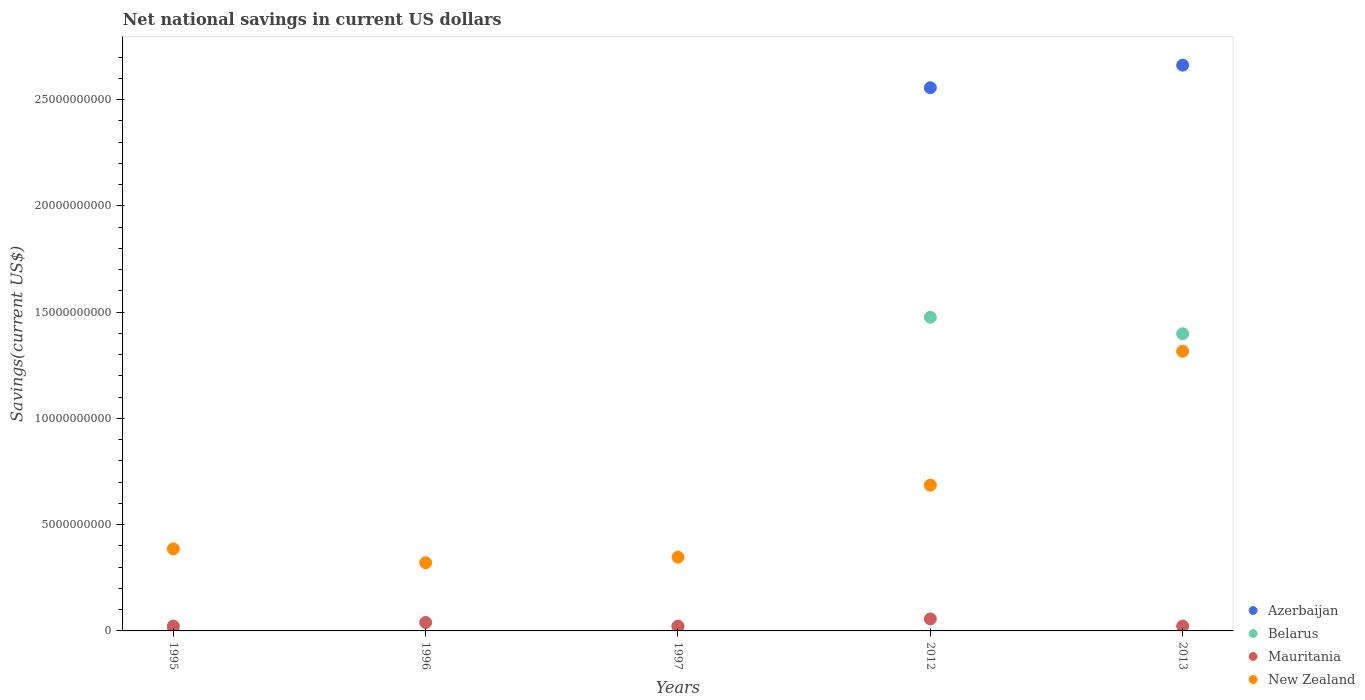How many different coloured dotlines are there?
Ensure brevity in your answer.  4. Across all years, what is the maximum net national savings in Mauritania?
Your answer should be compact. 5.65e+08. Across all years, what is the minimum net national savings in Mauritania?
Offer a terse response. 2.26e+08. In which year was the net national savings in Mauritania maximum?
Your response must be concise. 2012. What is the total net national savings in Mauritania in the graph?
Make the answer very short. 1.64e+09. What is the difference between the net national savings in New Zealand in 1997 and that in 2013?
Offer a very short reply. -9.69e+09. What is the difference between the net national savings in Mauritania in 1997 and the net national savings in Azerbaijan in 1996?
Offer a terse response. 2.26e+08. What is the average net national savings in Azerbaijan per year?
Make the answer very short. 1.04e+1. In the year 2012, what is the difference between the net national savings in New Zealand and net national savings in Belarus?
Keep it short and to the point. -7.90e+09. What is the ratio of the net national savings in Mauritania in 1996 to that in 2012?
Ensure brevity in your answer.  0.71. Is the difference between the net national savings in New Zealand in 1997 and 2013 greater than the difference between the net national savings in Belarus in 1997 and 2013?
Your answer should be very brief. Yes. What is the difference between the highest and the second highest net national savings in Belarus?
Offer a terse response. 7.80e+08. What is the difference between the highest and the lowest net national savings in Belarus?
Ensure brevity in your answer.  1.48e+1. Is the sum of the net national savings in Mauritania in 1996 and 2012 greater than the maximum net national savings in Azerbaijan across all years?
Your answer should be very brief. No. Is it the case that in every year, the sum of the net national savings in New Zealand and net national savings in Belarus  is greater than the sum of net national savings in Mauritania and net national savings in Azerbaijan?
Your answer should be compact. No. Is the net national savings in Belarus strictly greater than the net national savings in Mauritania over the years?
Your answer should be compact. No. Is the net national savings in Azerbaijan strictly less than the net national savings in New Zealand over the years?
Offer a terse response. No. What is the difference between two consecutive major ticks on the Y-axis?
Offer a terse response. 5.00e+09. Are the values on the major ticks of Y-axis written in scientific E-notation?
Give a very brief answer. No. Does the graph contain any zero values?
Keep it short and to the point. Yes. What is the title of the graph?
Keep it short and to the point. Net national savings in current US dollars. Does "Dominican Republic" appear as one of the legend labels in the graph?
Ensure brevity in your answer.  No. What is the label or title of the Y-axis?
Provide a succinct answer. Savings(current US$). What is the Savings(current US$) in Mauritania in 1995?
Ensure brevity in your answer.  2.28e+08. What is the Savings(current US$) in New Zealand in 1995?
Keep it short and to the point. 3.86e+09. What is the Savings(current US$) of Mauritania in 1996?
Keep it short and to the point. 3.98e+08. What is the Savings(current US$) of New Zealand in 1996?
Keep it short and to the point. 3.21e+09. What is the Savings(current US$) in Belarus in 1997?
Ensure brevity in your answer.  2.06e+08. What is the Savings(current US$) in Mauritania in 1997?
Keep it short and to the point. 2.26e+08. What is the Savings(current US$) in New Zealand in 1997?
Ensure brevity in your answer.  3.47e+09. What is the Savings(current US$) of Azerbaijan in 2012?
Ensure brevity in your answer.  2.56e+1. What is the Savings(current US$) in Belarus in 2012?
Your answer should be compact. 1.48e+1. What is the Savings(current US$) in Mauritania in 2012?
Your answer should be very brief. 5.65e+08. What is the Savings(current US$) of New Zealand in 2012?
Provide a short and direct response. 6.86e+09. What is the Savings(current US$) in Azerbaijan in 2013?
Provide a succinct answer. 2.66e+1. What is the Savings(current US$) in Belarus in 2013?
Offer a terse response. 1.40e+1. What is the Savings(current US$) of Mauritania in 2013?
Your response must be concise. 2.26e+08. What is the Savings(current US$) in New Zealand in 2013?
Give a very brief answer. 1.32e+1. Across all years, what is the maximum Savings(current US$) of Azerbaijan?
Keep it short and to the point. 2.66e+1. Across all years, what is the maximum Savings(current US$) in Belarus?
Your response must be concise. 1.48e+1. Across all years, what is the maximum Savings(current US$) of Mauritania?
Give a very brief answer. 5.65e+08. Across all years, what is the maximum Savings(current US$) in New Zealand?
Make the answer very short. 1.32e+1. Across all years, what is the minimum Savings(current US$) of Azerbaijan?
Ensure brevity in your answer.  0. Across all years, what is the minimum Savings(current US$) of Mauritania?
Provide a succinct answer. 2.26e+08. Across all years, what is the minimum Savings(current US$) in New Zealand?
Ensure brevity in your answer.  3.21e+09. What is the total Savings(current US$) of Azerbaijan in the graph?
Keep it short and to the point. 5.22e+1. What is the total Savings(current US$) in Belarus in the graph?
Offer a terse response. 2.90e+1. What is the total Savings(current US$) of Mauritania in the graph?
Make the answer very short. 1.64e+09. What is the total Savings(current US$) of New Zealand in the graph?
Your response must be concise. 3.06e+1. What is the difference between the Savings(current US$) in Mauritania in 1995 and that in 1996?
Make the answer very short. -1.70e+08. What is the difference between the Savings(current US$) in New Zealand in 1995 and that in 1996?
Ensure brevity in your answer.  6.53e+08. What is the difference between the Savings(current US$) of Mauritania in 1995 and that in 1997?
Offer a terse response. 2.21e+06. What is the difference between the Savings(current US$) in New Zealand in 1995 and that in 1997?
Provide a succinct answer. 3.91e+08. What is the difference between the Savings(current US$) of Mauritania in 1995 and that in 2012?
Your answer should be very brief. -3.37e+08. What is the difference between the Savings(current US$) of New Zealand in 1995 and that in 2012?
Give a very brief answer. -3.00e+09. What is the difference between the Savings(current US$) in Mauritania in 1995 and that in 2013?
Your answer should be very brief. 1.68e+06. What is the difference between the Savings(current US$) in New Zealand in 1995 and that in 2013?
Offer a very short reply. -9.30e+09. What is the difference between the Savings(current US$) in Mauritania in 1996 and that in 1997?
Make the answer very short. 1.72e+08. What is the difference between the Savings(current US$) of New Zealand in 1996 and that in 1997?
Ensure brevity in your answer.  -2.62e+08. What is the difference between the Savings(current US$) of Mauritania in 1996 and that in 2012?
Provide a short and direct response. -1.67e+08. What is the difference between the Savings(current US$) of New Zealand in 1996 and that in 2012?
Offer a terse response. -3.65e+09. What is the difference between the Savings(current US$) of Mauritania in 1996 and that in 2013?
Your answer should be compact. 1.72e+08. What is the difference between the Savings(current US$) in New Zealand in 1996 and that in 2013?
Keep it short and to the point. -9.95e+09. What is the difference between the Savings(current US$) of Belarus in 1997 and that in 2012?
Your answer should be compact. -1.46e+1. What is the difference between the Savings(current US$) in Mauritania in 1997 and that in 2012?
Provide a succinct answer. -3.39e+08. What is the difference between the Savings(current US$) in New Zealand in 1997 and that in 2012?
Give a very brief answer. -3.39e+09. What is the difference between the Savings(current US$) of Belarus in 1997 and that in 2013?
Ensure brevity in your answer.  -1.38e+1. What is the difference between the Savings(current US$) in Mauritania in 1997 and that in 2013?
Make the answer very short. -5.27e+05. What is the difference between the Savings(current US$) in New Zealand in 1997 and that in 2013?
Provide a short and direct response. -9.69e+09. What is the difference between the Savings(current US$) of Azerbaijan in 2012 and that in 2013?
Your answer should be compact. -1.06e+09. What is the difference between the Savings(current US$) of Belarus in 2012 and that in 2013?
Offer a very short reply. 7.80e+08. What is the difference between the Savings(current US$) of Mauritania in 2012 and that in 2013?
Your response must be concise. 3.38e+08. What is the difference between the Savings(current US$) of New Zealand in 2012 and that in 2013?
Provide a short and direct response. -6.30e+09. What is the difference between the Savings(current US$) in Mauritania in 1995 and the Savings(current US$) in New Zealand in 1996?
Keep it short and to the point. -2.98e+09. What is the difference between the Savings(current US$) in Mauritania in 1995 and the Savings(current US$) in New Zealand in 1997?
Provide a succinct answer. -3.24e+09. What is the difference between the Savings(current US$) of Mauritania in 1995 and the Savings(current US$) of New Zealand in 2012?
Your response must be concise. -6.63e+09. What is the difference between the Savings(current US$) in Mauritania in 1995 and the Savings(current US$) in New Zealand in 2013?
Provide a short and direct response. -1.29e+1. What is the difference between the Savings(current US$) in Mauritania in 1996 and the Savings(current US$) in New Zealand in 1997?
Your answer should be very brief. -3.07e+09. What is the difference between the Savings(current US$) in Mauritania in 1996 and the Savings(current US$) in New Zealand in 2012?
Ensure brevity in your answer.  -6.46e+09. What is the difference between the Savings(current US$) of Mauritania in 1996 and the Savings(current US$) of New Zealand in 2013?
Provide a succinct answer. -1.28e+1. What is the difference between the Savings(current US$) of Belarus in 1997 and the Savings(current US$) of Mauritania in 2012?
Ensure brevity in your answer.  -3.59e+08. What is the difference between the Savings(current US$) in Belarus in 1997 and the Savings(current US$) in New Zealand in 2012?
Offer a very short reply. -6.65e+09. What is the difference between the Savings(current US$) in Mauritania in 1997 and the Savings(current US$) in New Zealand in 2012?
Your answer should be compact. -6.63e+09. What is the difference between the Savings(current US$) of Belarus in 1997 and the Savings(current US$) of Mauritania in 2013?
Your response must be concise. -2.03e+07. What is the difference between the Savings(current US$) in Belarus in 1997 and the Savings(current US$) in New Zealand in 2013?
Offer a very short reply. -1.30e+1. What is the difference between the Savings(current US$) of Mauritania in 1997 and the Savings(current US$) of New Zealand in 2013?
Your response must be concise. -1.29e+1. What is the difference between the Savings(current US$) in Azerbaijan in 2012 and the Savings(current US$) in Belarus in 2013?
Provide a succinct answer. 1.16e+1. What is the difference between the Savings(current US$) of Azerbaijan in 2012 and the Savings(current US$) of Mauritania in 2013?
Keep it short and to the point. 2.53e+1. What is the difference between the Savings(current US$) of Azerbaijan in 2012 and the Savings(current US$) of New Zealand in 2013?
Offer a very short reply. 1.24e+1. What is the difference between the Savings(current US$) in Belarus in 2012 and the Savings(current US$) in Mauritania in 2013?
Your answer should be very brief. 1.45e+1. What is the difference between the Savings(current US$) in Belarus in 2012 and the Savings(current US$) in New Zealand in 2013?
Provide a succinct answer. 1.60e+09. What is the difference between the Savings(current US$) in Mauritania in 2012 and the Savings(current US$) in New Zealand in 2013?
Your response must be concise. -1.26e+1. What is the average Savings(current US$) in Azerbaijan per year?
Provide a short and direct response. 1.04e+1. What is the average Savings(current US$) in Belarus per year?
Give a very brief answer. 5.79e+09. What is the average Savings(current US$) in Mauritania per year?
Provide a short and direct response. 3.28e+08. What is the average Savings(current US$) of New Zealand per year?
Keep it short and to the point. 6.11e+09. In the year 1995, what is the difference between the Savings(current US$) in Mauritania and Savings(current US$) in New Zealand?
Your response must be concise. -3.63e+09. In the year 1996, what is the difference between the Savings(current US$) of Mauritania and Savings(current US$) of New Zealand?
Provide a succinct answer. -2.81e+09. In the year 1997, what is the difference between the Savings(current US$) in Belarus and Savings(current US$) in Mauritania?
Your response must be concise. -1.97e+07. In the year 1997, what is the difference between the Savings(current US$) of Belarus and Savings(current US$) of New Zealand?
Your answer should be compact. -3.26e+09. In the year 1997, what is the difference between the Savings(current US$) of Mauritania and Savings(current US$) of New Zealand?
Ensure brevity in your answer.  -3.24e+09. In the year 2012, what is the difference between the Savings(current US$) in Azerbaijan and Savings(current US$) in Belarus?
Your answer should be very brief. 1.08e+1. In the year 2012, what is the difference between the Savings(current US$) of Azerbaijan and Savings(current US$) of Mauritania?
Your answer should be compact. 2.50e+1. In the year 2012, what is the difference between the Savings(current US$) in Azerbaijan and Savings(current US$) in New Zealand?
Your response must be concise. 1.87e+1. In the year 2012, what is the difference between the Savings(current US$) in Belarus and Savings(current US$) in Mauritania?
Give a very brief answer. 1.42e+1. In the year 2012, what is the difference between the Savings(current US$) in Belarus and Savings(current US$) in New Zealand?
Provide a short and direct response. 7.90e+09. In the year 2012, what is the difference between the Savings(current US$) in Mauritania and Savings(current US$) in New Zealand?
Provide a short and direct response. -6.30e+09. In the year 2013, what is the difference between the Savings(current US$) of Azerbaijan and Savings(current US$) of Belarus?
Provide a succinct answer. 1.26e+1. In the year 2013, what is the difference between the Savings(current US$) of Azerbaijan and Savings(current US$) of Mauritania?
Ensure brevity in your answer.  2.64e+1. In the year 2013, what is the difference between the Savings(current US$) in Azerbaijan and Savings(current US$) in New Zealand?
Make the answer very short. 1.35e+1. In the year 2013, what is the difference between the Savings(current US$) in Belarus and Savings(current US$) in Mauritania?
Offer a terse response. 1.38e+1. In the year 2013, what is the difference between the Savings(current US$) in Belarus and Savings(current US$) in New Zealand?
Your answer should be compact. 8.24e+08. In the year 2013, what is the difference between the Savings(current US$) in Mauritania and Savings(current US$) in New Zealand?
Keep it short and to the point. -1.29e+1. What is the ratio of the Savings(current US$) of Mauritania in 1995 to that in 1996?
Provide a succinct answer. 0.57. What is the ratio of the Savings(current US$) of New Zealand in 1995 to that in 1996?
Your response must be concise. 1.2. What is the ratio of the Savings(current US$) of Mauritania in 1995 to that in 1997?
Keep it short and to the point. 1.01. What is the ratio of the Savings(current US$) of New Zealand in 1995 to that in 1997?
Give a very brief answer. 1.11. What is the ratio of the Savings(current US$) of Mauritania in 1995 to that in 2012?
Your answer should be very brief. 0.4. What is the ratio of the Savings(current US$) of New Zealand in 1995 to that in 2012?
Ensure brevity in your answer.  0.56. What is the ratio of the Savings(current US$) of Mauritania in 1995 to that in 2013?
Give a very brief answer. 1.01. What is the ratio of the Savings(current US$) in New Zealand in 1995 to that in 2013?
Make the answer very short. 0.29. What is the ratio of the Savings(current US$) of Mauritania in 1996 to that in 1997?
Provide a short and direct response. 1.76. What is the ratio of the Savings(current US$) in New Zealand in 1996 to that in 1997?
Give a very brief answer. 0.92. What is the ratio of the Savings(current US$) of Mauritania in 1996 to that in 2012?
Your response must be concise. 0.7. What is the ratio of the Savings(current US$) in New Zealand in 1996 to that in 2012?
Keep it short and to the point. 0.47. What is the ratio of the Savings(current US$) in Mauritania in 1996 to that in 2013?
Provide a succinct answer. 1.76. What is the ratio of the Savings(current US$) of New Zealand in 1996 to that in 2013?
Provide a succinct answer. 0.24. What is the ratio of the Savings(current US$) of Belarus in 1997 to that in 2012?
Provide a short and direct response. 0.01. What is the ratio of the Savings(current US$) in Mauritania in 1997 to that in 2012?
Provide a succinct answer. 0.4. What is the ratio of the Savings(current US$) of New Zealand in 1997 to that in 2012?
Your answer should be very brief. 0.51. What is the ratio of the Savings(current US$) of Belarus in 1997 to that in 2013?
Ensure brevity in your answer.  0.01. What is the ratio of the Savings(current US$) of New Zealand in 1997 to that in 2013?
Give a very brief answer. 0.26. What is the ratio of the Savings(current US$) in Azerbaijan in 2012 to that in 2013?
Your answer should be compact. 0.96. What is the ratio of the Savings(current US$) of Belarus in 2012 to that in 2013?
Your answer should be very brief. 1.06. What is the ratio of the Savings(current US$) of Mauritania in 2012 to that in 2013?
Offer a very short reply. 2.5. What is the ratio of the Savings(current US$) in New Zealand in 2012 to that in 2013?
Provide a short and direct response. 0.52. What is the difference between the highest and the second highest Savings(current US$) in Belarus?
Give a very brief answer. 7.80e+08. What is the difference between the highest and the second highest Savings(current US$) in Mauritania?
Keep it short and to the point. 1.67e+08. What is the difference between the highest and the second highest Savings(current US$) of New Zealand?
Provide a succinct answer. 6.30e+09. What is the difference between the highest and the lowest Savings(current US$) in Azerbaijan?
Make the answer very short. 2.66e+1. What is the difference between the highest and the lowest Savings(current US$) in Belarus?
Give a very brief answer. 1.48e+1. What is the difference between the highest and the lowest Savings(current US$) in Mauritania?
Keep it short and to the point. 3.39e+08. What is the difference between the highest and the lowest Savings(current US$) of New Zealand?
Make the answer very short. 9.95e+09. 